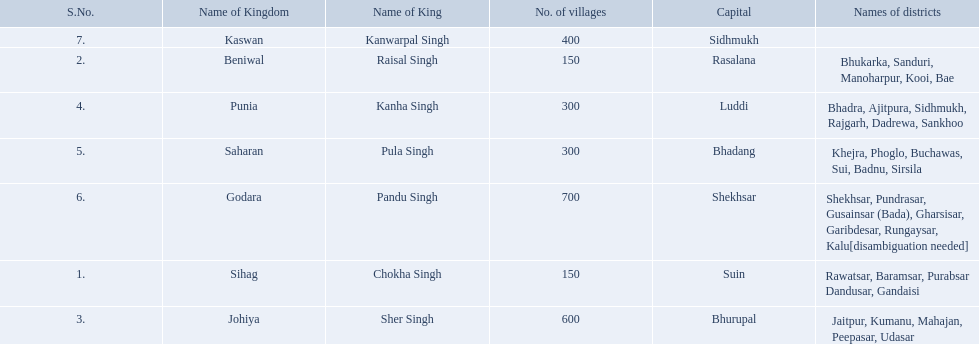What is the most amount of villages in a kingdom? 700. What is the second most amount of villages in a kingdom? 600. What kingdom has 600 villages? Johiya. 